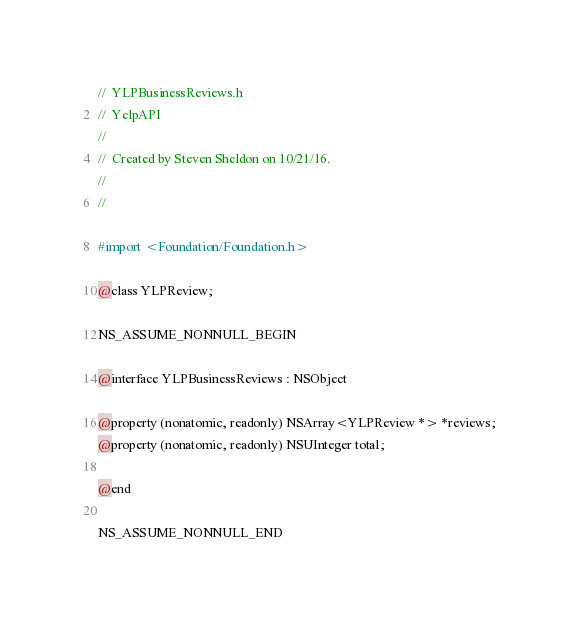<code> <loc_0><loc_0><loc_500><loc_500><_C_>//  YLPBusinessReviews.h
//  YelpAPI
//
//  Created by Steven Sheldon on 10/21/16.
//
//

#import <Foundation/Foundation.h>

@class YLPReview;

NS_ASSUME_NONNULL_BEGIN

@interface YLPBusinessReviews : NSObject

@property (nonatomic, readonly) NSArray<YLPReview *> *reviews;
@property (nonatomic, readonly) NSUInteger total;

@end

NS_ASSUME_NONNULL_END
</code> 